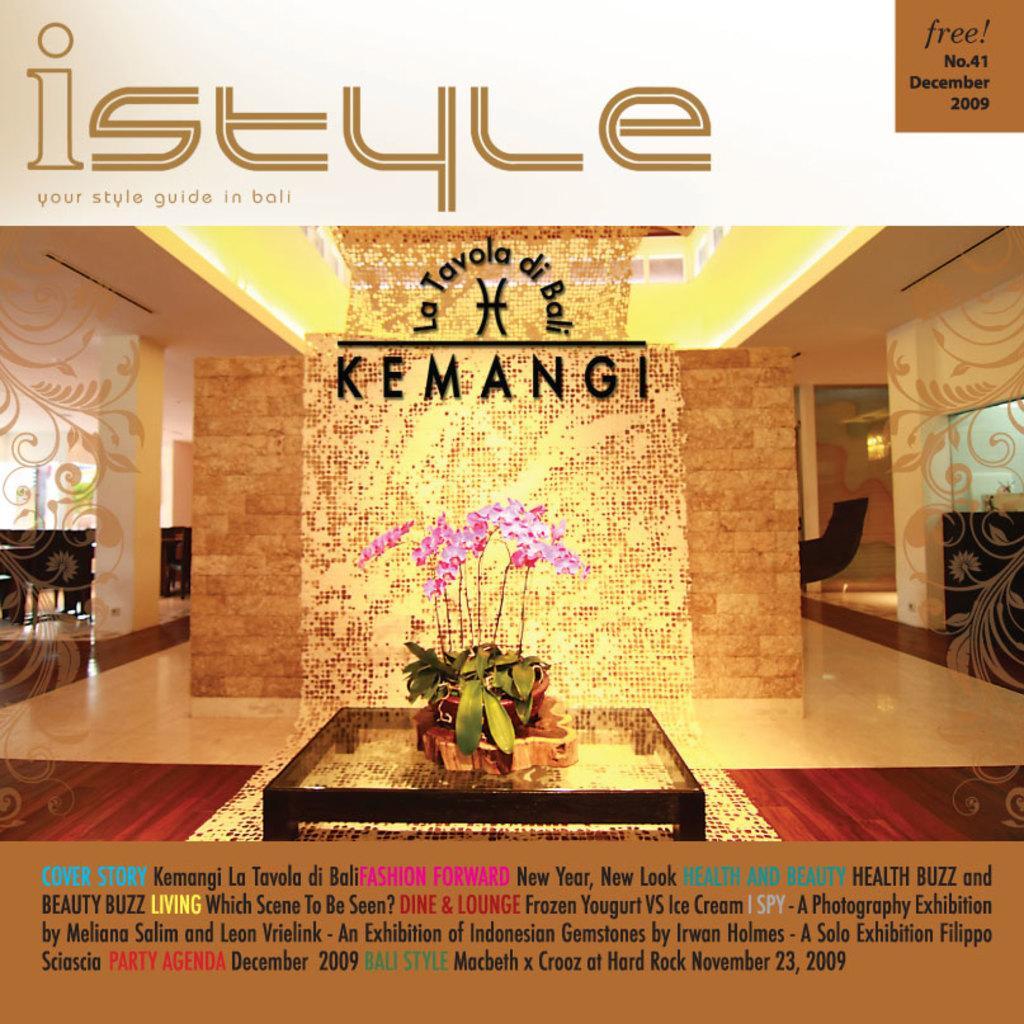Could you give a brief overview of what you see in this image? In this image we can see an advertisement. In the center there is a stand and we can see a flower vase placed on the stand. There is a wall and a door. At the bottom and top there is text. 